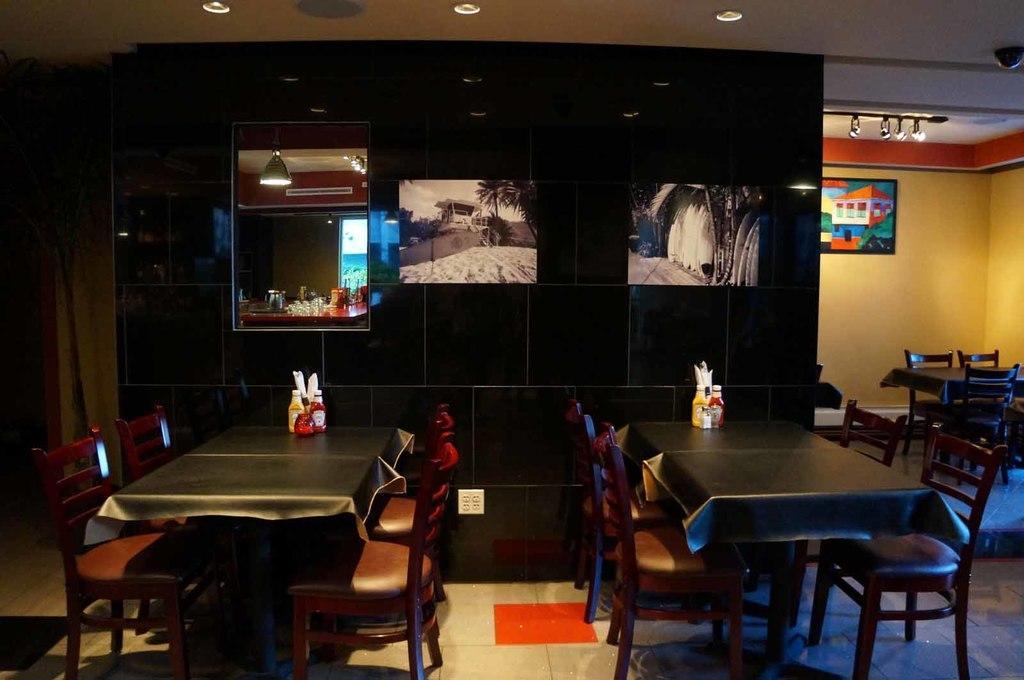Can you describe this image briefly? In this picture we can see bottles on tables, chairs on the floor, frames on the wall, lights and in the background we can see some objects. 